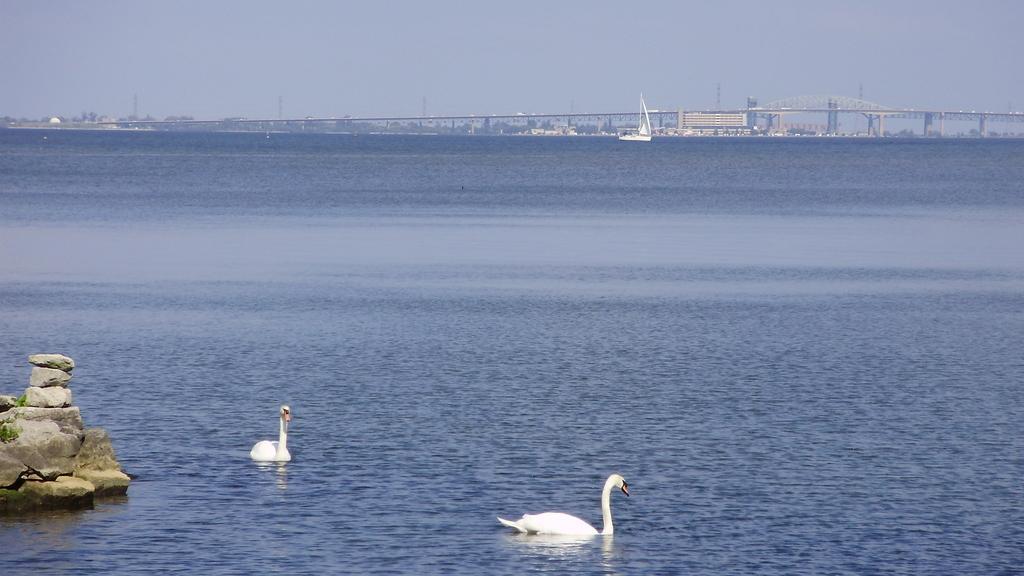Describe this image in one or two sentences. There are birds on the surface of water and stones on the left side in the foreground, there are buildings, a ship, boles, vehicles, it seems like a bridge and the sky in the background area. 